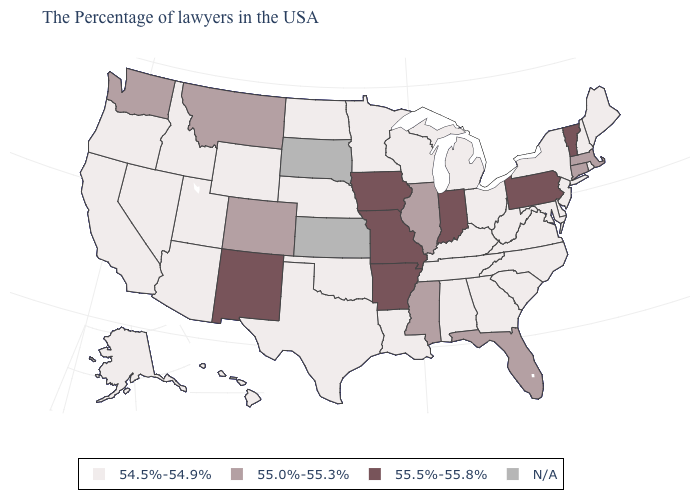What is the value of New Hampshire?
Answer briefly. 54.5%-54.9%. Name the states that have a value in the range 54.5%-54.9%?
Concise answer only. Maine, Rhode Island, New Hampshire, New York, New Jersey, Delaware, Maryland, Virginia, North Carolina, South Carolina, West Virginia, Ohio, Georgia, Michigan, Kentucky, Alabama, Tennessee, Wisconsin, Louisiana, Minnesota, Nebraska, Oklahoma, Texas, North Dakota, Wyoming, Utah, Arizona, Idaho, Nevada, California, Oregon, Alaska, Hawaii. What is the highest value in states that border Missouri?
Be succinct. 55.5%-55.8%. Does Vermont have the highest value in the Northeast?
Concise answer only. Yes. What is the lowest value in the West?
Be succinct. 54.5%-54.9%. Does the first symbol in the legend represent the smallest category?
Be succinct. Yes. Which states have the highest value in the USA?
Answer briefly. Vermont, Pennsylvania, Indiana, Missouri, Arkansas, Iowa, New Mexico. Does Oklahoma have the highest value in the South?
Quick response, please. No. What is the value of Oregon?
Keep it brief. 54.5%-54.9%. Does the map have missing data?
Write a very short answer. Yes. Name the states that have a value in the range 54.5%-54.9%?
Short answer required. Maine, Rhode Island, New Hampshire, New York, New Jersey, Delaware, Maryland, Virginia, North Carolina, South Carolina, West Virginia, Ohio, Georgia, Michigan, Kentucky, Alabama, Tennessee, Wisconsin, Louisiana, Minnesota, Nebraska, Oklahoma, Texas, North Dakota, Wyoming, Utah, Arizona, Idaho, Nevada, California, Oregon, Alaska, Hawaii. Does New Mexico have the lowest value in the West?
Answer briefly. No. Which states have the lowest value in the MidWest?
Give a very brief answer. Ohio, Michigan, Wisconsin, Minnesota, Nebraska, North Dakota. 